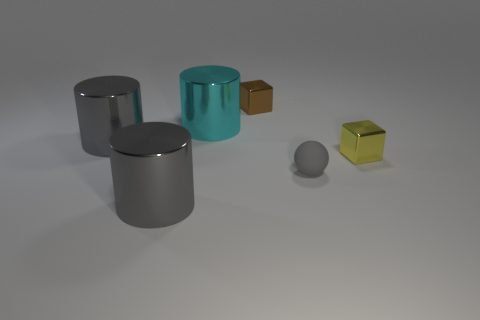How many gray objects are both in front of the small gray sphere and to the right of the tiny brown metal object? Upon careful examination of the image, it appears that there are no gray objects that meet both criteria of being in front of the small gray sphere and to the right of the tiny brown metal object. The objects in the image have been closely scrutinized, and only one gray cylinder is slightly to the right of the brown object but is also behind the small gray sphere, disqualifying it from meeting both conditions. 